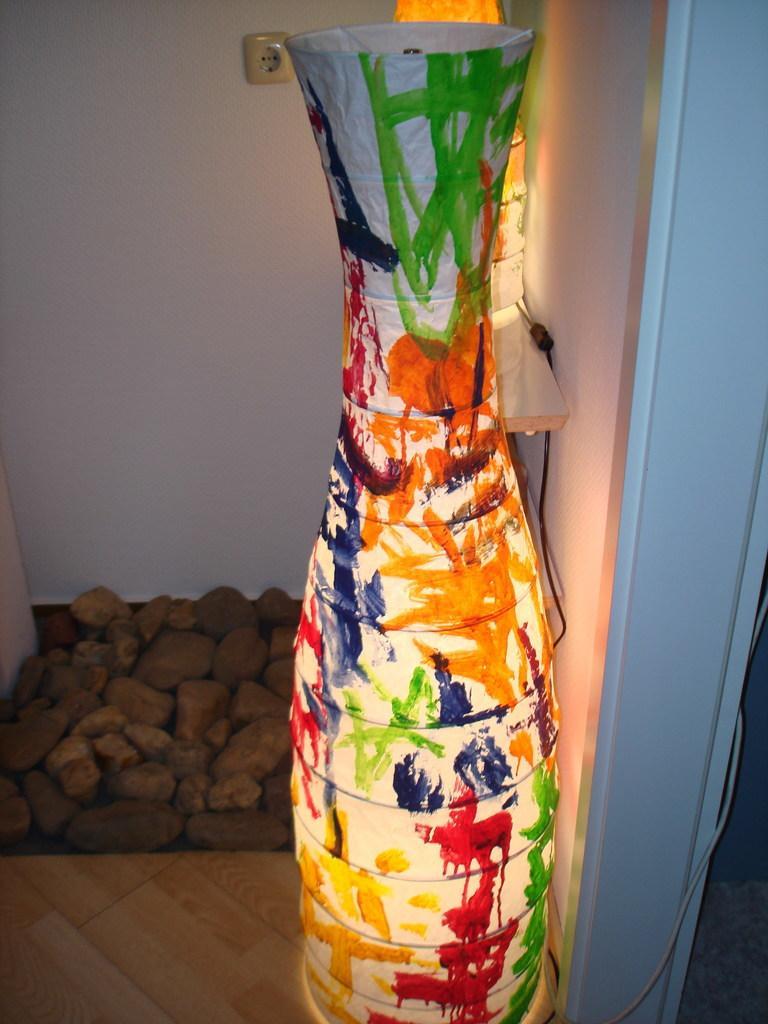Could you give a brief overview of what you see in this image? In this image we can see light, wall and stones. 